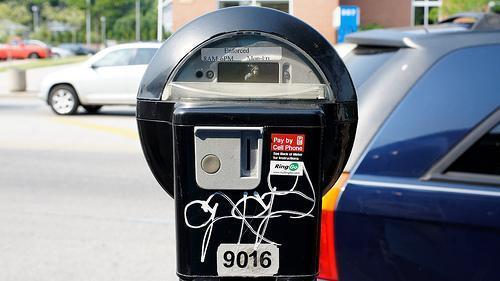How many meters?
Give a very brief answer. 1. How many parking meters are shown?
Give a very brief answer. 1. How many numbers are on the parking meter?
Give a very brief answer. 4. 